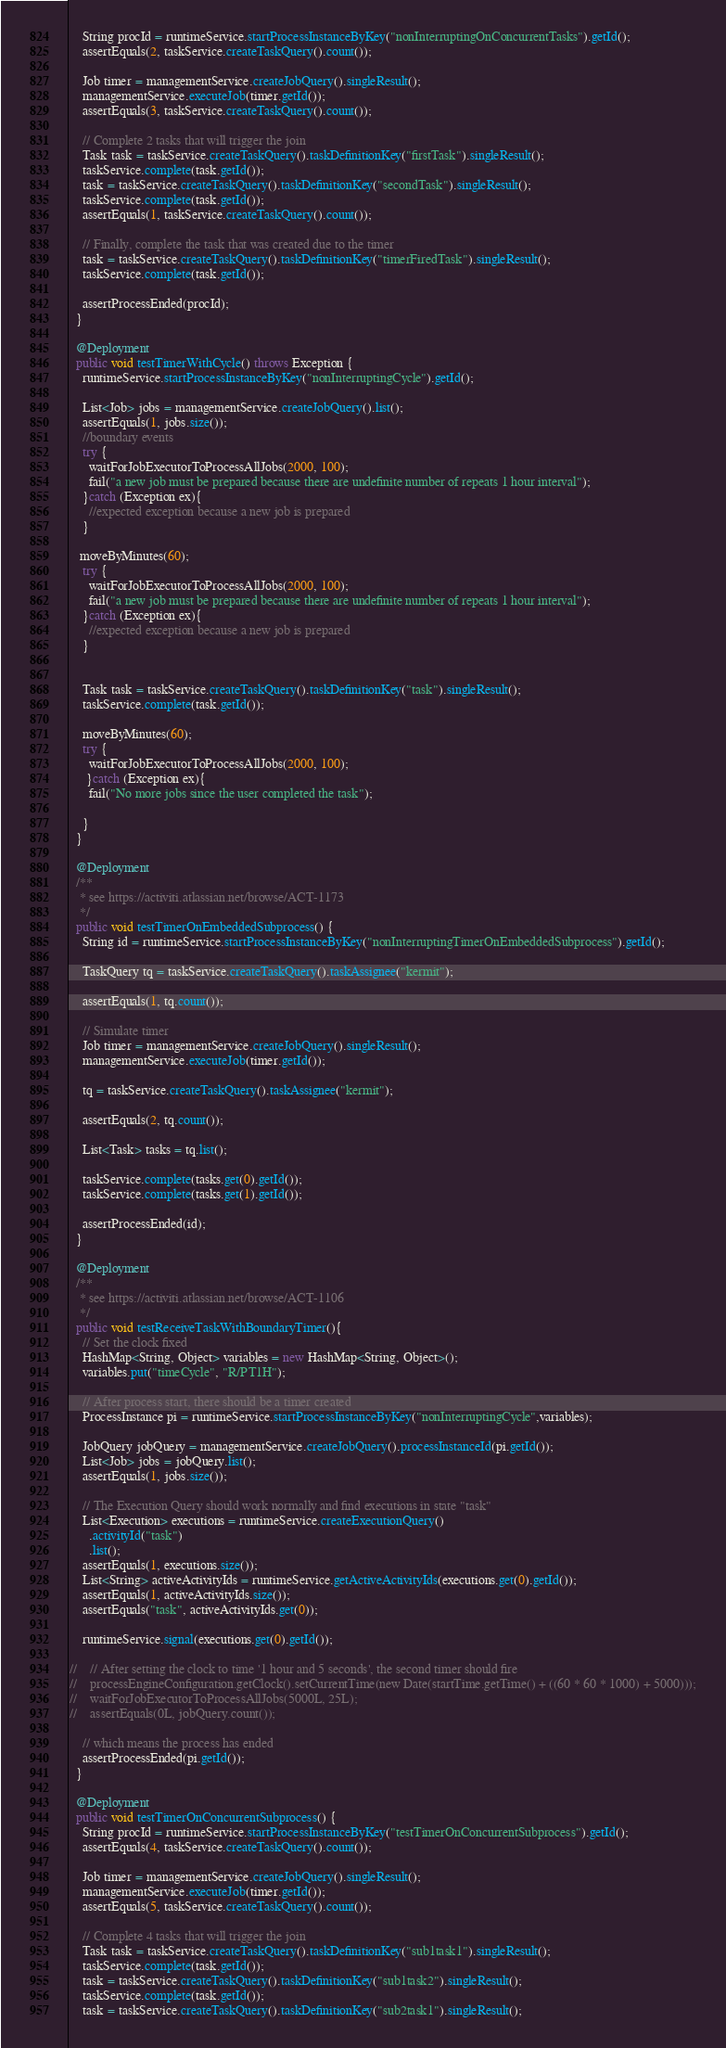<code> <loc_0><loc_0><loc_500><loc_500><_Java_>    String procId = runtimeService.startProcessInstanceByKey("nonInterruptingOnConcurrentTasks").getId();
    assertEquals(2, taskService.createTaskQuery().count());
    
    Job timer = managementService.createJobQuery().singleResult();
    managementService.executeJob(timer.getId());
    assertEquals(3, taskService.createTaskQuery().count());
    
    // Complete 2 tasks that will trigger the join
    Task task = taskService.createTaskQuery().taskDefinitionKey("firstTask").singleResult();
    taskService.complete(task.getId());
    task = taskService.createTaskQuery().taskDefinitionKey("secondTask").singleResult();
    taskService.complete(task.getId());
    assertEquals(1, taskService.createTaskQuery().count());
    
    // Finally, complete the task that was created due to the timer 
    task = taskService.createTaskQuery().taskDefinitionKey("timerFiredTask").singleResult();
    taskService.complete(task.getId());
    
    assertProcessEnded(procId);
  }

  @Deployment
  public void testTimerWithCycle() throws Exception {
    runtimeService.startProcessInstanceByKey("nonInterruptingCycle").getId();

    List<Job> jobs = managementService.createJobQuery().list();
    assertEquals(1, jobs.size());
    //boundary events
    try {
      waitForJobExecutorToProcessAllJobs(2000, 100);
      fail("a new job must be prepared because there are undefinite number of repeats 1 hour interval");
    }catch (Exception ex){
      //expected exception because a new job is prepared
    }

   moveByMinutes(60);
    try {
      waitForJobExecutorToProcessAllJobs(2000, 100);
      fail("a new job must be prepared because there are undefinite number of repeats 1 hour interval");
    }catch (Exception ex){
      //expected exception because a new job is prepared
    }


    Task task = taskService.createTaskQuery().taskDefinitionKey("task").singleResult();
    taskService.complete(task.getId());

    moveByMinutes(60);
    try {
      waitForJobExecutorToProcessAllJobs(2000, 100);
     }catch (Exception ex){
      fail("No more jobs since the user completed the task");

    }
  }
  
  @Deployment
  /**
   * see https://activiti.atlassian.net/browse/ACT-1173
   */
  public void testTimerOnEmbeddedSubprocess() {
    String id = runtimeService.startProcessInstanceByKey("nonInterruptingTimerOnEmbeddedSubprocess").getId();
    
    TaskQuery tq = taskService.createTaskQuery().taskAssignee("kermit");
    
    assertEquals(1, tq.count());
    
    // Simulate timer
    Job timer = managementService.createJobQuery().singleResult();
    managementService.executeJob(timer.getId());
    
    tq = taskService.createTaskQuery().taskAssignee("kermit");
    
    assertEquals(2, tq.count());
    
    List<Task> tasks = tq.list(); 
    
    taskService.complete(tasks.get(0).getId());
    taskService.complete(tasks.get(1).getId());
    
    assertProcessEnded(id);
  }
  
  @Deployment
  /**
   * see https://activiti.atlassian.net/browse/ACT-1106
   */
  public void testReceiveTaskWithBoundaryTimer(){
    // Set the clock fixed
    HashMap<String, Object> variables = new HashMap<String, Object>();
    variables.put("timeCycle", "R/PT1H");
    
    // After process start, there should be a timer created
    ProcessInstance pi = runtimeService.startProcessInstanceByKey("nonInterruptingCycle",variables);

    JobQuery jobQuery = managementService.createJobQuery().processInstanceId(pi.getId());
    List<Job> jobs = jobQuery.list();
    assertEquals(1, jobs.size());
    
    // The Execution Query should work normally and find executions in state "task"
    List<Execution> executions = runtimeService.createExecutionQuery()
      .activityId("task")
      .list();
    assertEquals(1, executions.size());
    List<String> activeActivityIds = runtimeService.getActiveActivityIds(executions.get(0).getId());
    assertEquals(1, activeActivityIds.size());
    assertEquals("task", activeActivityIds.get(0));
    
    runtimeService.signal(executions.get(0).getId());

//    // After setting the clock to time '1 hour and 5 seconds', the second timer should fire
//    processEngineConfiguration.getClock().setCurrentTime(new Date(startTime.getTime() + ((60 * 60 * 1000) + 5000)));
//    waitForJobExecutorToProcessAllJobs(5000L, 25L);
//    assertEquals(0L, jobQuery.count());

    // which means the process has ended
    assertProcessEnded(pi.getId());
  }  
  
  @Deployment
  public void testTimerOnConcurrentSubprocess() {
    String procId = runtimeService.startProcessInstanceByKey("testTimerOnConcurrentSubprocess").getId();
    assertEquals(4, taskService.createTaskQuery().count());
    
    Job timer = managementService.createJobQuery().singleResult();
    managementService.executeJob(timer.getId());
    assertEquals(5, taskService.createTaskQuery().count());
    
    // Complete 4 tasks that will trigger the join
    Task task = taskService.createTaskQuery().taskDefinitionKey("sub1task1").singleResult();
    taskService.complete(task.getId());
    task = taskService.createTaskQuery().taskDefinitionKey("sub1task2").singleResult();
    taskService.complete(task.getId());
    task = taskService.createTaskQuery().taskDefinitionKey("sub2task1").singleResult();</code> 